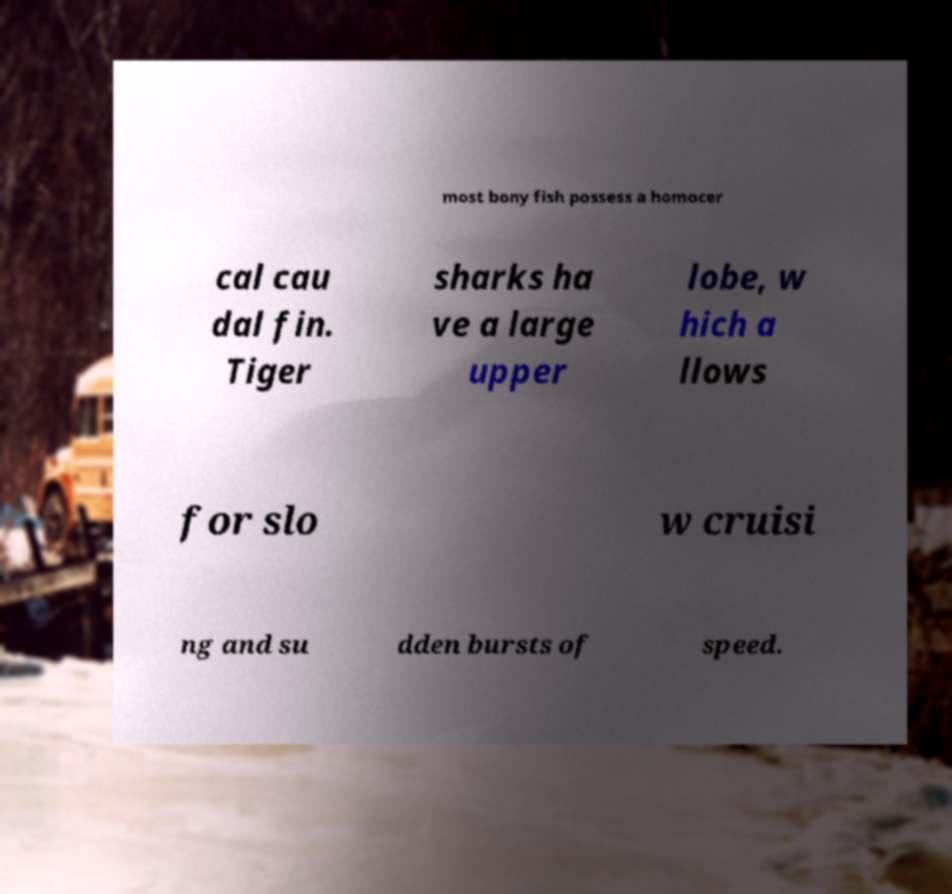Please identify and transcribe the text found in this image. most bony fish possess a homocer cal cau dal fin. Tiger sharks ha ve a large upper lobe, w hich a llows for slo w cruisi ng and su dden bursts of speed. 